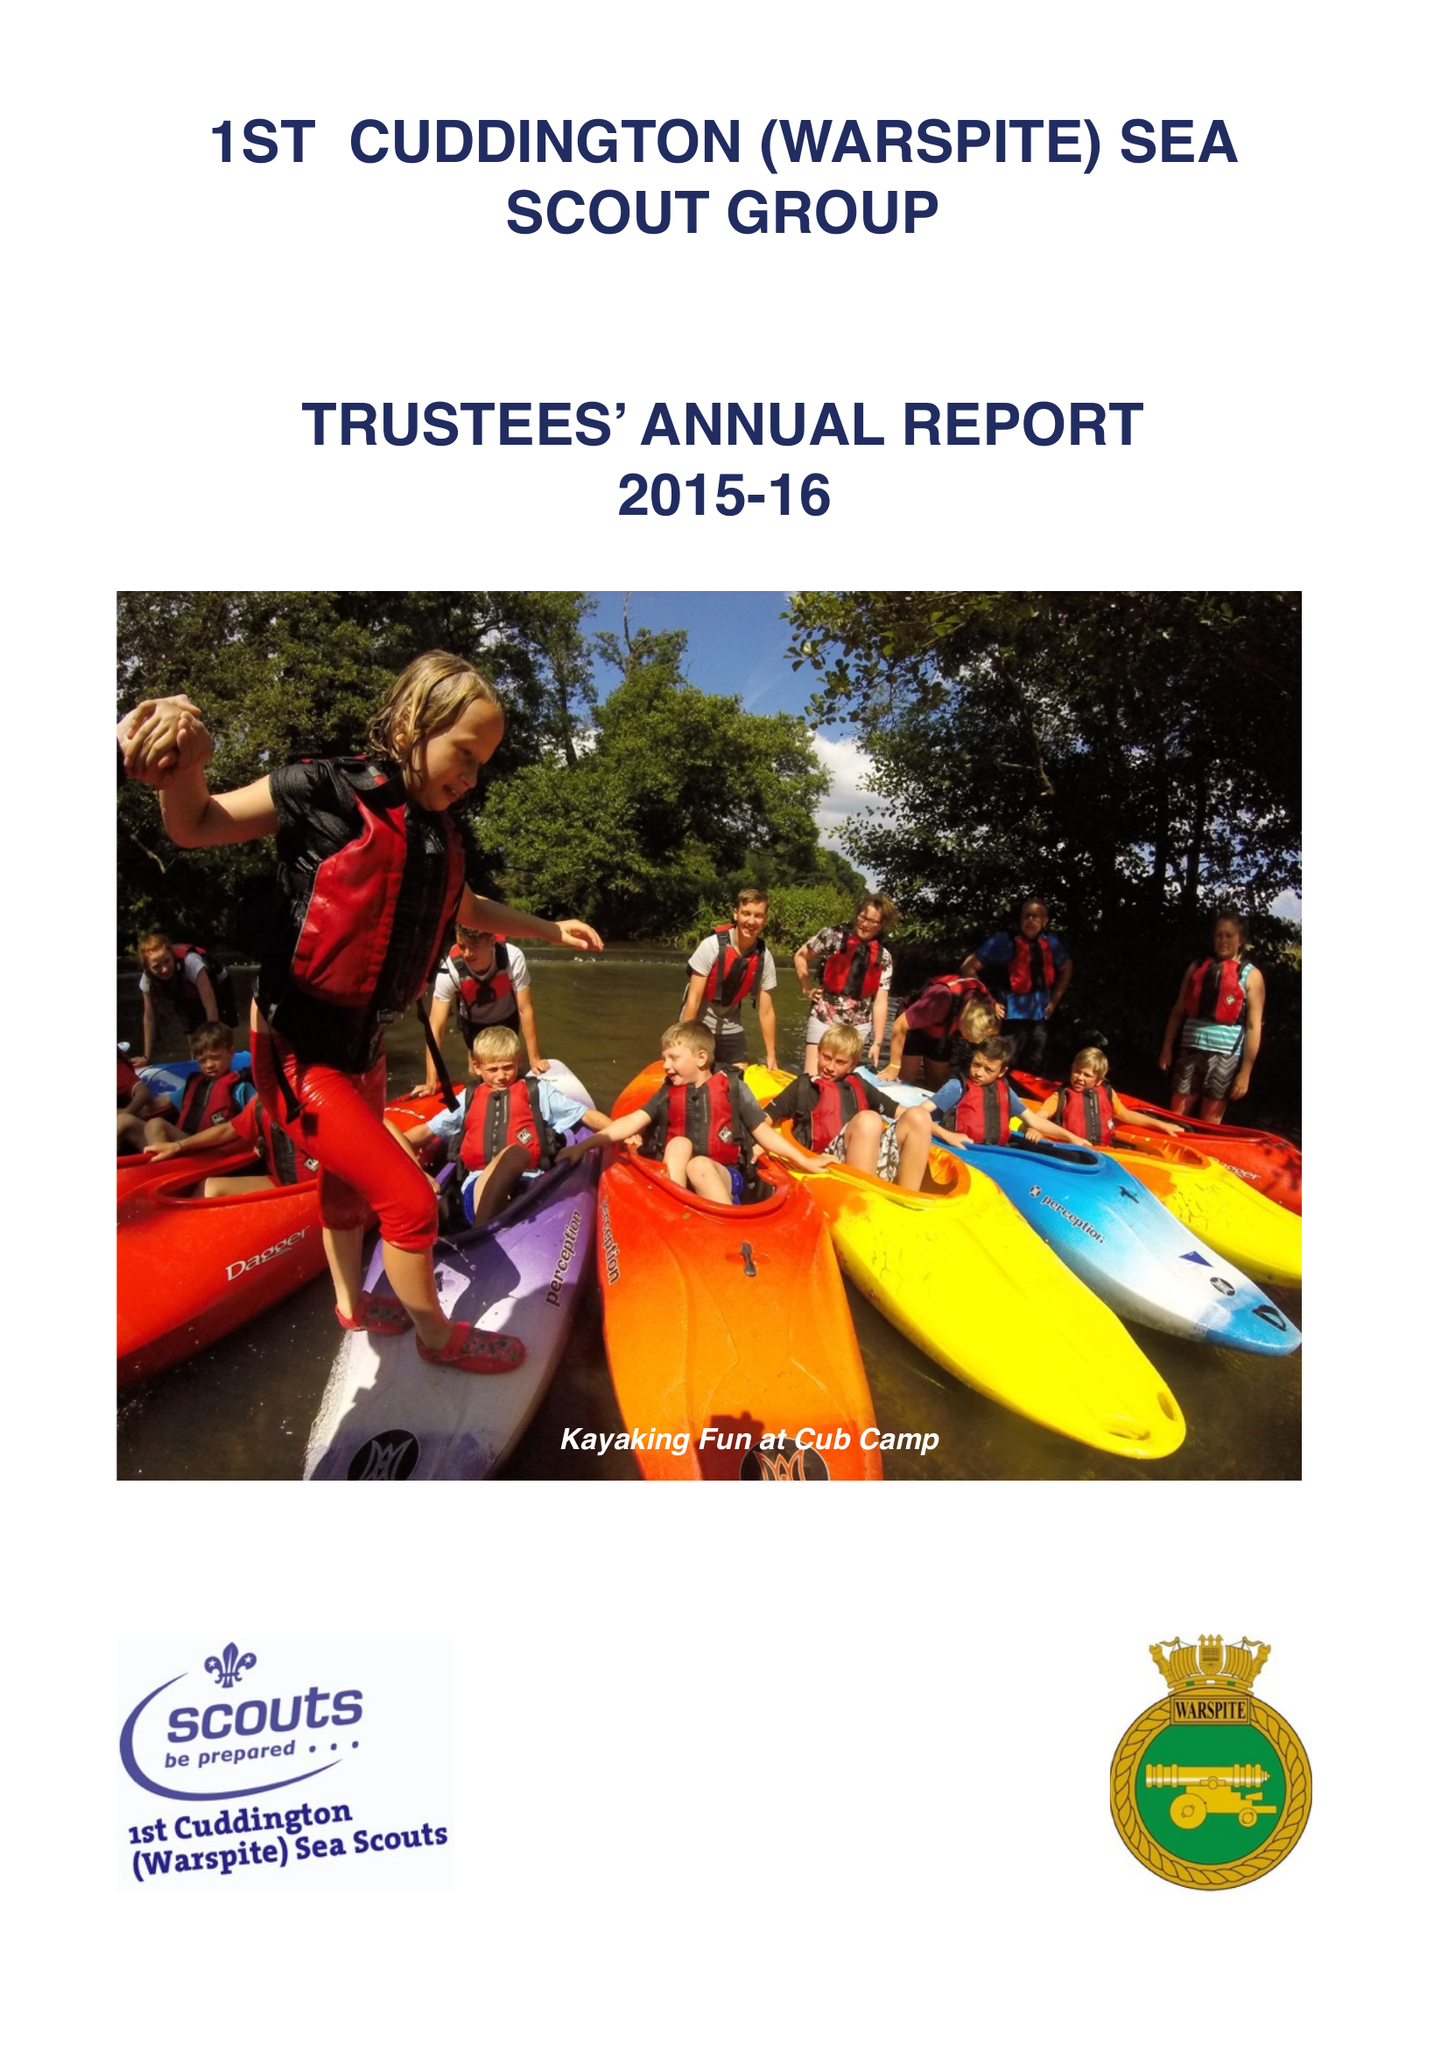What is the value for the address__post_town?
Answer the question using a single word or phrase. None 